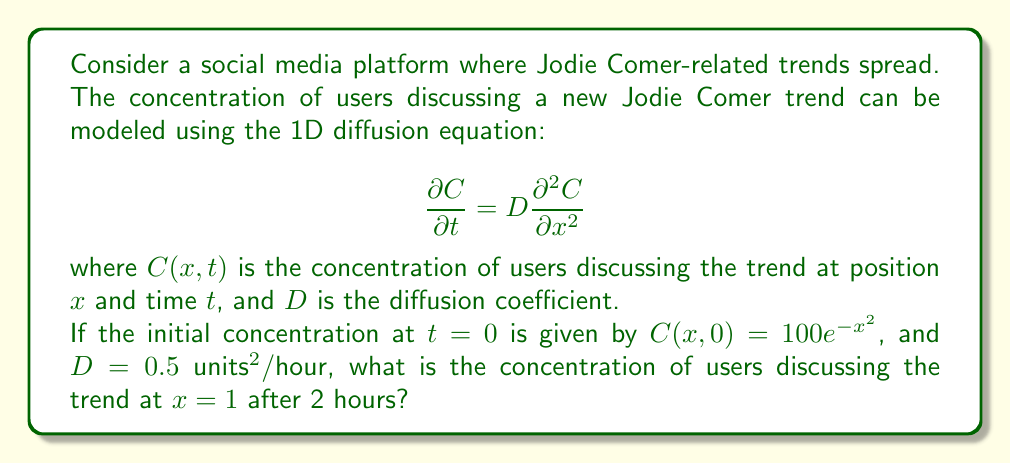Give your solution to this math problem. To solve this problem, we need to use the solution to the 1D diffusion equation with an initial Gaussian distribution. The general solution is:

$$C(x,t) = \frac{M}{\sqrt{4\pi Dt}} e^{-\frac{x^2}{4Dt}}$$

where $M$ is the total amount of the initial distribution.

1) First, we need to find $M$ by integrating the initial distribution:

   $$M = \int_{-\infty}^{\infty} 100e^{-x^2} dx = 100\sqrt{\pi}$$

2) Now we can substitute this into our general solution:

   $$C(x,t) = \frac{100\sqrt{\pi}}{\sqrt{4\pi Dt}} e^{-\frac{x^2}{4Dt}}$$

3) Simplify:

   $$C(x,t) = \frac{50}{\sqrt{Dt}} e^{-\frac{x^2}{4Dt}}$$

4) Now we can substitute our known values: $D = 0.5$, $t = 2$, and $x = 1$:

   $$C(1,2) = \frac{50}{\sqrt{0.5 \cdot 2}} e^{-\frac{1^2}{4 \cdot 0.5 \cdot 2}}$$

5) Simplify:

   $$C(1,2) = \frac{50}{\sqrt{1}} e^{-\frac{1}{4}} = 50 e^{-0.25}$$

6) Calculate the final value:

   $$C(1,2) \approx 39.35$$

Therefore, the concentration of users discussing the trend at $x=1$ after 2 hours is approximately 39.35 units.
Answer: $39.35$ units 